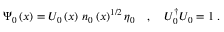<formula> <loc_0><loc_0><loc_500><loc_500>\Psi _ { 0 } \left ( x \right ) = U _ { 0 } \left ( x \right ) \, n _ { 0 } \left ( x \right ) ^ { 1 / 2 } \eta _ { 0 } \quad , \quad U _ { 0 } ^ { \dagger } U _ { 0 } = 1 \, .</formula> 